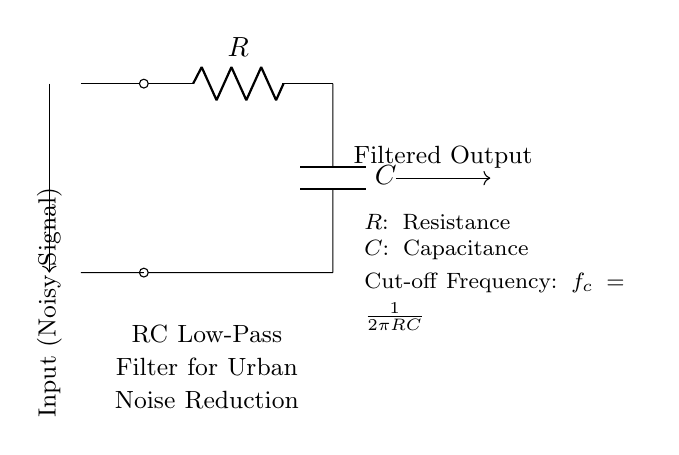What are the components in this circuit? The diagram shows a resistor (R) and a capacitor (C) arranged in series to form an RC low-pass filter.
Answer: Resistor and Capacitor What is the function of this circuit? This circuit acts as a low-pass filter, which allows low-frequency signals to pass while attenuating high-frequency noise, making it suitable for noise reduction applications.
Answer: Noise filtering What is the cut-off frequency of the filter? The cut-off frequency can be calculated using the formula f_c = 1/(2πRC), where R is the resistance and C is the capacitance. The frequency defines the point at which the output starts to decrease significantly.
Answer: 1/(2πRC) How does increasing the resistance affect the cut-off frequency? Increasing the resistance (R) will lower the cut-off frequency (f_c), allowing fewer high-frequency signals to pass through, thus enhancing noise reduction.
Answer: Lowers frequency What is the output of this RC filter in terms of signal characteristics? The output of this RC filter will have a smoother waveform compared to the input noisy signal, emphasizing the low-frequency components and suppressing high-frequency noise.
Answer: Smoother waveform What kind of signal is fed into this circuit? The input signal is a noisy signal, which typically contains a mix of different frequencies and unwanted high-frequency noise components that need to be filtered out.
Answer: Noisy Signal 